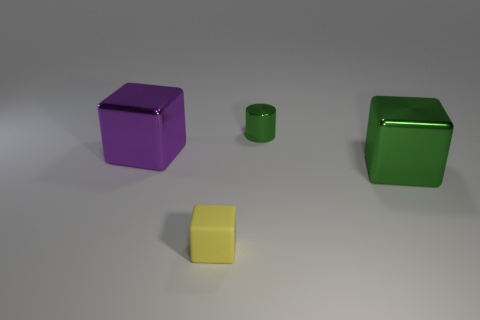Add 2 tiny shiny objects. How many objects exist? 6 Subtract all big green rubber spheres. Subtract all tiny metallic cylinders. How many objects are left? 3 Add 1 green cylinders. How many green cylinders are left? 2 Add 3 tiny cyan rubber spheres. How many tiny cyan rubber spheres exist? 3 Subtract all green cubes. How many cubes are left? 2 Subtract all green cubes. How many cubes are left? 2 Subtract 0 red spheres. How many objects are left? 4 Subtract all cylinders. How many objects are left? 3 Subtract 2 blocks. How many blocks are left? 1 Subtract all yellow cylinders. Subtract all yellow spheres. How many cylinders are left? 1 